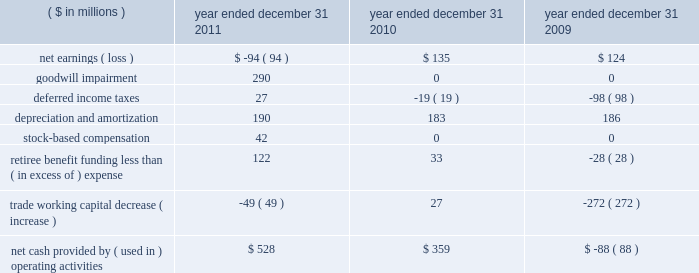Construction of cvn-79 john f .
Kennedy , construction of the u.s .
Coast guard 2019s fifth national security cutter ( unnamed ) , advance planning efforts for the cvn-72 uss abraham lincoln rcoh , and continued execution of the cvn-71 uss theodore roosevelt rcoh .
2010 2014the value of new contract awards during the year ended december 31 , 2010 , was approximately $ 3.6 billion .
Significant new awards during this period included $ 480 million for the construction of the u.s .
Coast guard 2019s fourth national security cutter hamilton , $ 480 million for design and long-lead material procurement activities for the cvn-79 john f .
Kennedy aircraft carrier , $ 377 million for cvn-78 gerald r .
Ford , $ 224 million for lha-7 ( unnamed ) , $ 184 million for lpd-26 john p .
Murtha , $ 114 million for ddg-114 ralph johnson and $ 62 million for long-lead material procurement activities for lpd-27 ( unnamed ) .
Liquidity and capital resources we endeavor to ensure the most efficient conversion of operating results into cash for deployment in operating our businesses and maximizing stockholder value .
We use various financial measures to assist in capital deployment decision making , including net cash provided by operating activities and free cash flow .
We believe these measures are useful to investors in assessing our financial performance .
The table below summarizes key components of cash flow provided by ( used in ) operating activities: .
Cash flows we discuss below our major operating , investing and financing activities for each of the three years in the period ended december 31 , 2011 , as classified on our consolidated statements of cash flows .
Operating activities 2011 2014cash provided by operating activities was $ 528 million in 2011 compared with $ 359 million in 2010 .
The increase of $ 169 million was due principally to increased earnings net of impairment charges and lower pension contributions , offset by an increase in trade working capital .
Net cash paid by northrop grumman on our behalf for u.s .
Federal income tax obligations was $ 53 million .
We expect cash generated from operations for 2012 to be sufficient to service debt , meet contract obligations , and finance capital expenditures .
Although 2012 cash from operations is expected to be sufficient to service these obligations , we may from time to time borrow funds under our credit facility to accommodate timing differences in cash flows .
2010 2014net cash provided by operating activities was $ 359 million in 2010 compared with cash used of $ 88 million in 2009 .
The change of $ 447 million was due principally to a decrease in discretionary pension contributions of $ 97 million , a decrease in trade working capital of $ 299 million , and a decrease in deferred income taxes of $ 79 million .
In 2009 , trade working capital balances included the unfavorable impact of delayed customer billings associated with the negative performance adjustments on the lpd-22 through lpd-25 contract due to projected cost increases at completion .
See note 7 : contract charges in item 8 .
The change in deferred taxes was due principally to the timing of contract related deductions .
U.s .
Federal income tax payments made by northrop grumman on our behalf were $ 89 million in 2010. .
What was the percentage change of the net cash provided by ( used in ) operating activities from 2010 to 2011? 
Computations: (169 / 359)
Answer: 0.47075. Construction of cvn-79 john f .
Kennedy , construction of the u.s .
Coast guard 2019s fifth national security cutter ( unnamed ) , advance planning efforts for the cvn-72 uss abraham lincoln rcoh , and continued execution of the cvn-71 uss theodore roosevelt rcoh .
2010 2014the value of new contract awards during the year ended december 31 , 2010 , was approximately $ 3.6 billion .
Significant new awards during this period included $ 480 million for the construction of the u.s .
Coast guard 2019s fourth national security cutter hamilton , $ 480 million for design and long-lead material procurement activities for the cvn-79 john f .
Kennedy aircraft carrier , $ 377 million for cvn-78 gerald r .
Ford , $ 224 million for lha-7 ( unnamed ) , $ 184 million for lpd-26 john p .
Murtha , $ 114 million for ddg-114 ralph johnson and $ 62 million for long-lead material procurement activities for lpd-27 ( unnamed ) .
Liquidity and capital resources we endeavor to ensure the most efficient conversion of operating results into cash for deployment in operating our businesses and maximizing stockholder value .
We use various financial measures to assist in capital deployment decision making , including net cash provided by operating activities and free cash flow .
We believe these measures are useful to investors in assessing our financial performance .
The table below summarizes key components of cash flow provided by ( used in ) operating activities: .
Cash flows we discuss below our major operating , investing and financing activities for each of the three years in the period ended december 31 , 2011 , as classified on our consolidated statements of cash flows .
Operating activities 2011 2014cash provided by operating activities was $ 528 million in 2011 compared with $ 359 million in 2010 .
The increase of $ 169 million was due principally to increased earnings net of impairment charges and lower pension contributions , offset by an increase in trade working capital .
Net cash paid by northrop grumman on our behalf for u.s .
Federal income tax obligations was $ 53 million .
We expect cash generated from operations for 2012 to be sufficient to service debt , meet contract obligations , and finance capital expenditures .
Although 2012 cash from operations is expected to be sufficient to service these obligations , we may from time to time borrow funds under our credit facility to accommodate timing differences in cash flows .
2010 2014net cash provided by operating activities was $ 359 million in 2010 compared with cash used of $ 88 million in 2009 .
The change of $ 447 million was due principally to a decrease in discretionary pension contributions of $ 97 million , a decrease in trade working capital of $ 299 million , and a decrease in deferred income taxes of $ 79 million .
In 2009 , trade working capital balances included the unfavorable impact of delayed customer billings associated with the negative performance adjustments on the lpd-22 through lpd-25 contract due to projected cost increases at completion .
See note 7 : contract charges in item 8 .
The change in deferred taxes was due principally to the timing of contract related deductions .
U.s .
Federal income tax payments made by northrop grumman on our behalf were $ 89 million in 2010. .
What is the percentage change in net cash from operating activities from 2010 to 2011? 
Computations: ((528 - 359) / 359)
Answer: 0.47075. 